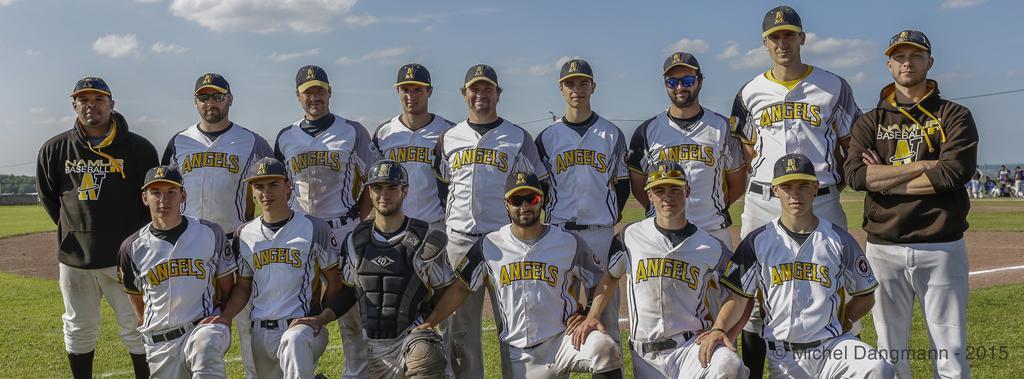Please provide a concise description of this image. In this image we can see few people in the ground and in the background there are few trees, a pole with wires and the sky with clouds. 